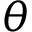<formula> <loc_0><loc_0><loc_500><loc_500>{ \theta }</formula> 